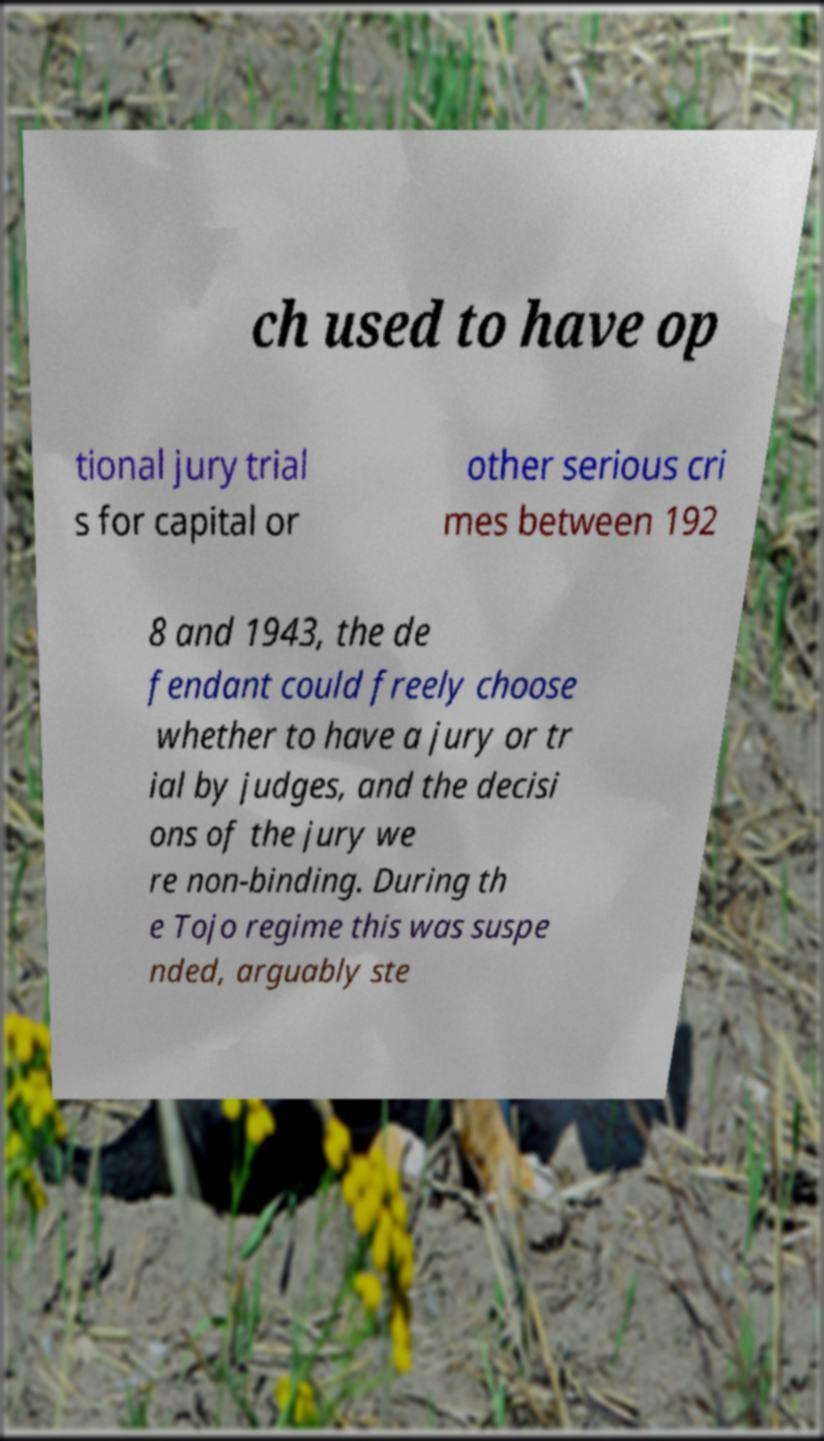Can you accurately transcribe the text from the provided image for me? ch used to have op tional jury trial s for capital or other serious cri mes between 192 8 and 1943, the de fendant could freely choose whether to have a jury or tr ial by judges, and the decisi ons of the jury we re non-binding. During th e Tojo regime this was suspe nded, arguably ste 